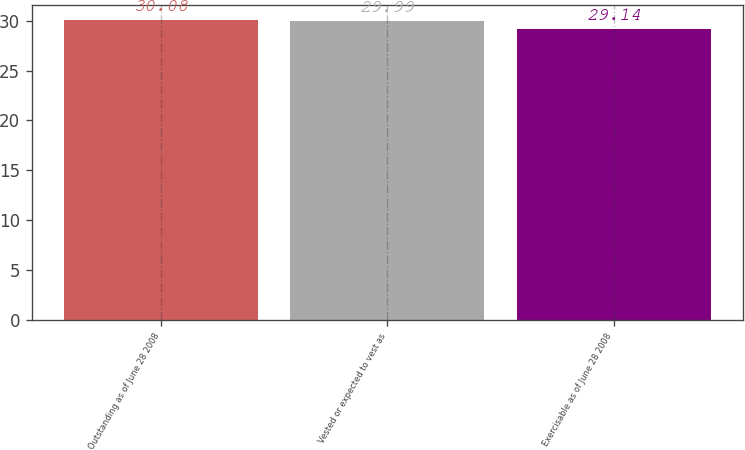<chart> <loc_0><loc_0><loc_500><loc_500><bar_chart><fcel>Outstanding as of June 28 2008<fcel>Vested or expected to vest as<fcel>Exercisable as of June 28 2008<nl><fcel>30.08<fcel>29.99<fcel>29.14<nl></chart> 